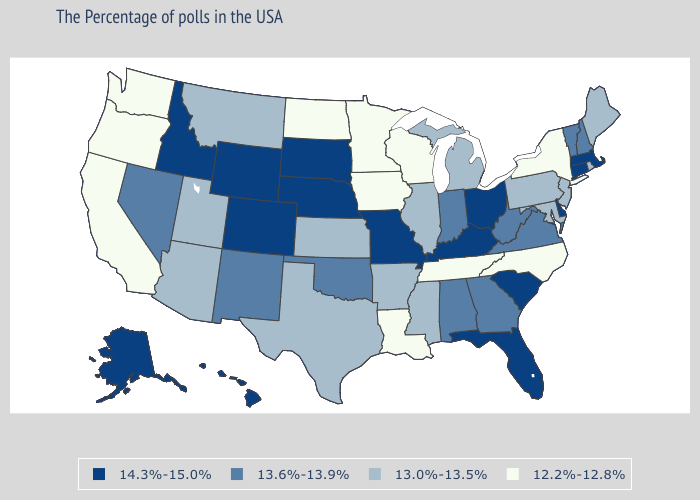Which states have the lowest value in the USA?
Concise answer only. New York, North Carolina, Tennessee, Wisconsin, Louisiana, Minnesota, Iowa, North Dakota, California, Washington, Oregon. What is the highest value in the Northeast ?
Concise answer only. 14.3%-15.0%. Among the states that border South Dakota , which have the highest value?
Concise answer only. Nebraska, Wyoming. Name the states that have a value in the range 13.0%-13.5%?
Give a very brief answer. Maine, Rhode Island, New Jersey, Maryland, Pennsylvania, Michigan, Illinois, Mississippi, Arkansas, Kansas, Texas, Utah, Montana, Arizona. Which states have the lowest value in the South?
Keep it brief. North Carolina, Tennessee, Louisiana. What is the value of Colorado?
Concise answer only. 14.3%-15.0%. What is the value of Georgia?
Keep it brief. 13.6%-13.9%. Among the states that border Maine , which have the highest value?
Be succinct. New Hampshire. Name the states that have a value in the range 14.3%-15.0%?
Short answer required. Massachusetts, Connecticut, Delaware, South Carolina, Ohio, Florida, Kentucky, Missouri, Nebraska, South Dakota, Wyoming, Colorado, Idaho, Alaska, Hawaii. Name the states that have a value in the range 12.2%-12.8%?
Answer briefly. New York, North Carolina, Tennessee, Wisconsin, Louisiana, Minnesota, Iowa, North Dakota, California, Washington, Oregon. Is the legend a continuous bar?
Write a very short answer. No. Does the map have missing data?
Answer briefly. No. What is the value of Missouri?
Quick response, please. 14.3%-15.0%. Which states have the highest value in the USA?
Concise answer only. Massachusetts, Connecticut, Delaware, South Carolina, Ohio, Florida, Kentucky, Missouri, Nebraska, South Dakota, Wyoming, Colorado, Idaho, Alaska, Hawaii. What is the highest value in states that border Nevada?
Be succinct. 14.3%-15.0%. 